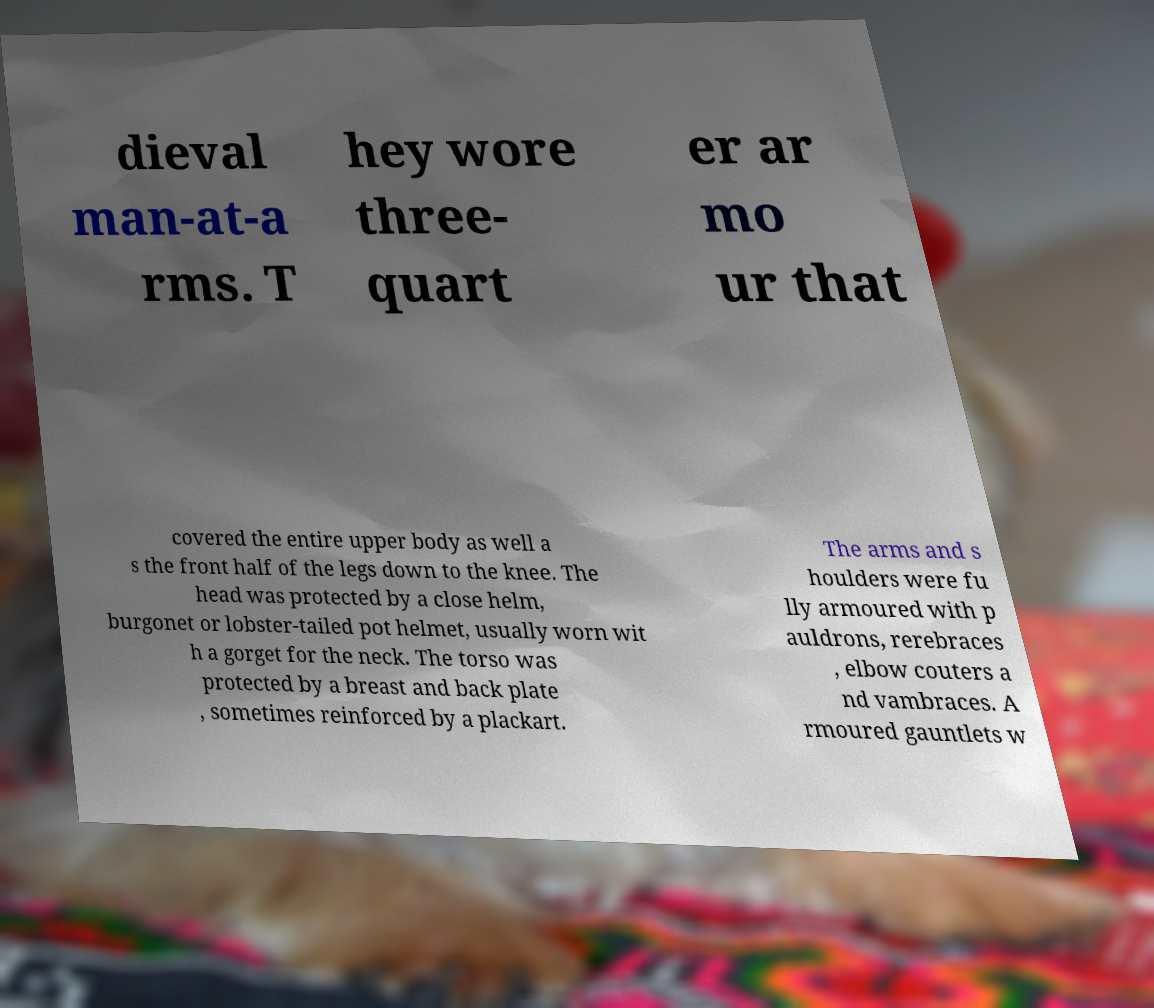There's text embedded in this image that I need extracted. Can you transcribe it verbatim? dieval man-at-a rms. T hey wore three- quart er ar mo ur that covered the entire upper body as well a s the front half of the legs down to the knee. The head was protected by a close helm, burgonet or lobster-tailed pot helmet, usually worn wit h a gorget for the neck. The torso was protected by a breast and back plate , sometimes reinforced by a plackart. The arms and s houlders were fu lly armoured with p auldrons, rerebraces , elbow couters a nd vambraces. A rmoured gauntlets w 